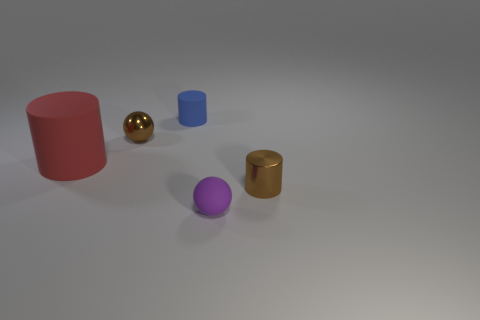Could you describe the shadows in the image? Each object casts a soft shadow directly opposite to its position in relation to the lighting source. The shadows are soft-edged, indicating a diffused light source, likely situated above and to the left of the objects. 